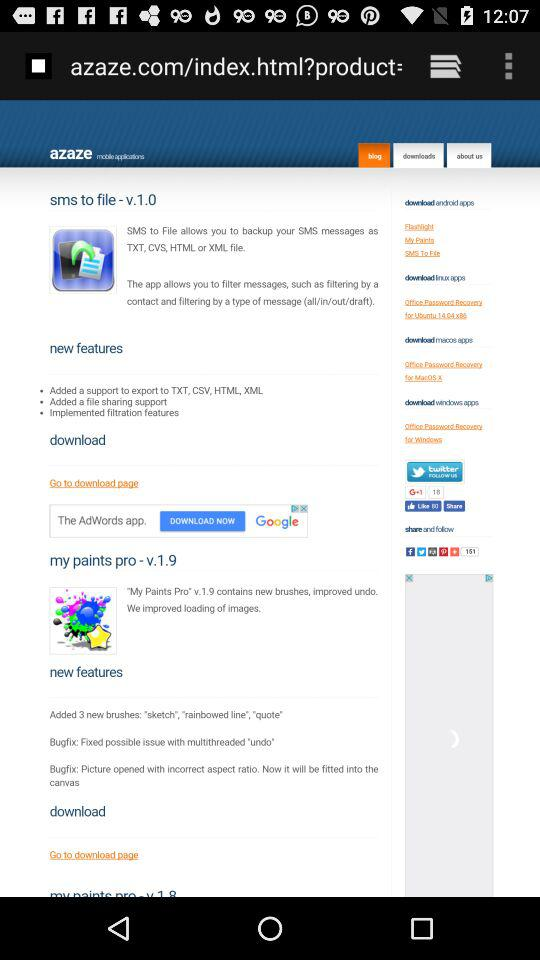What are the new features of the "sms to file" application? The new features are "Added a support to export to TXT, CSV, HTML, XML", "Added a file sharing support" and "Implemented filtration features". 